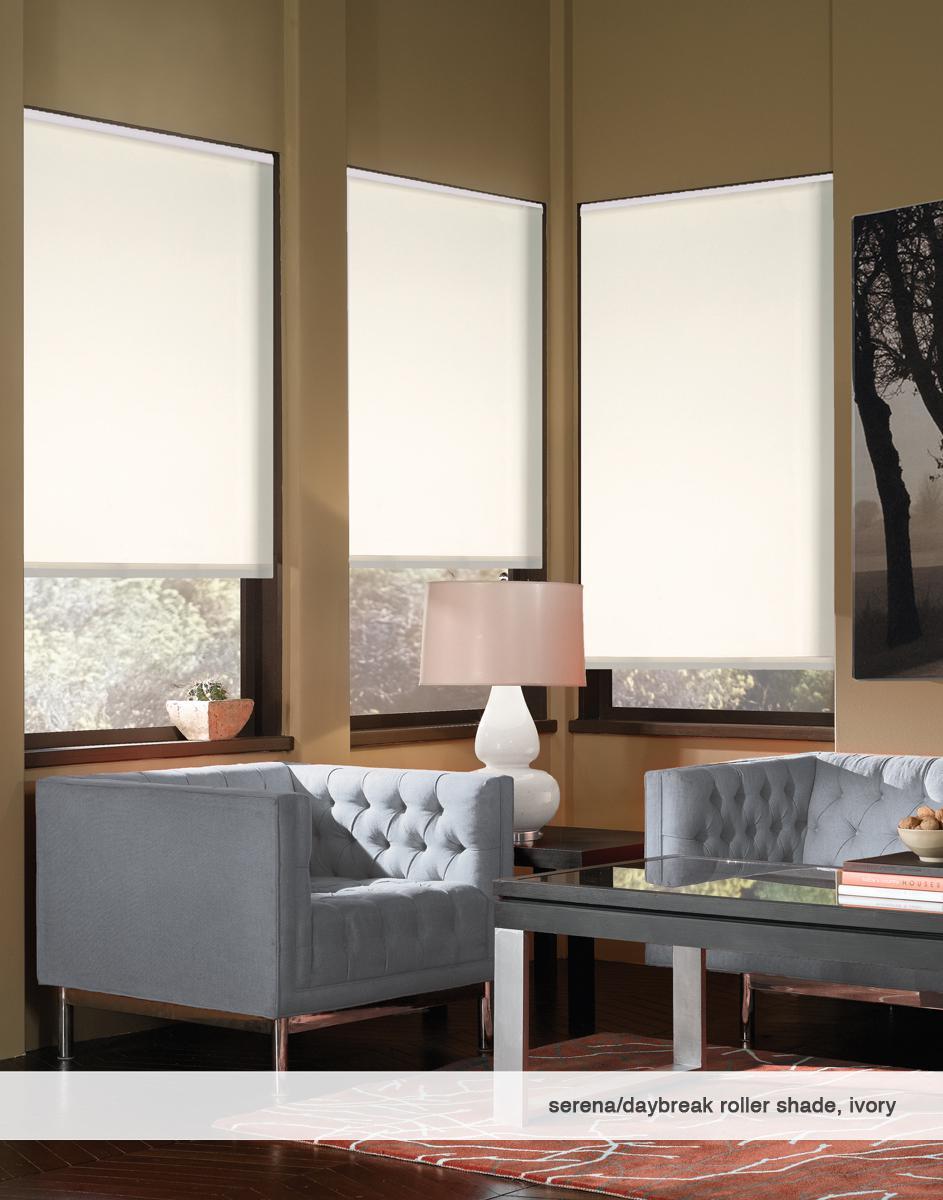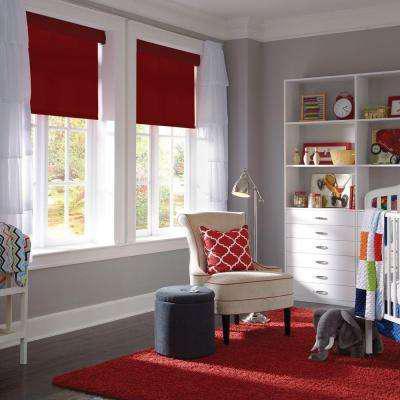The first image is the image on the left, the second image is the image on the right. Considering the images on both sides, is "There are three windows in a row that are on the same wall." valid? Answer yes or no. No. The first image is the image on the left, the second image is the image on the right. Given the left and right images, does the statement "At least one window shade is completely closed." hold true? Answer yes or no. No. 